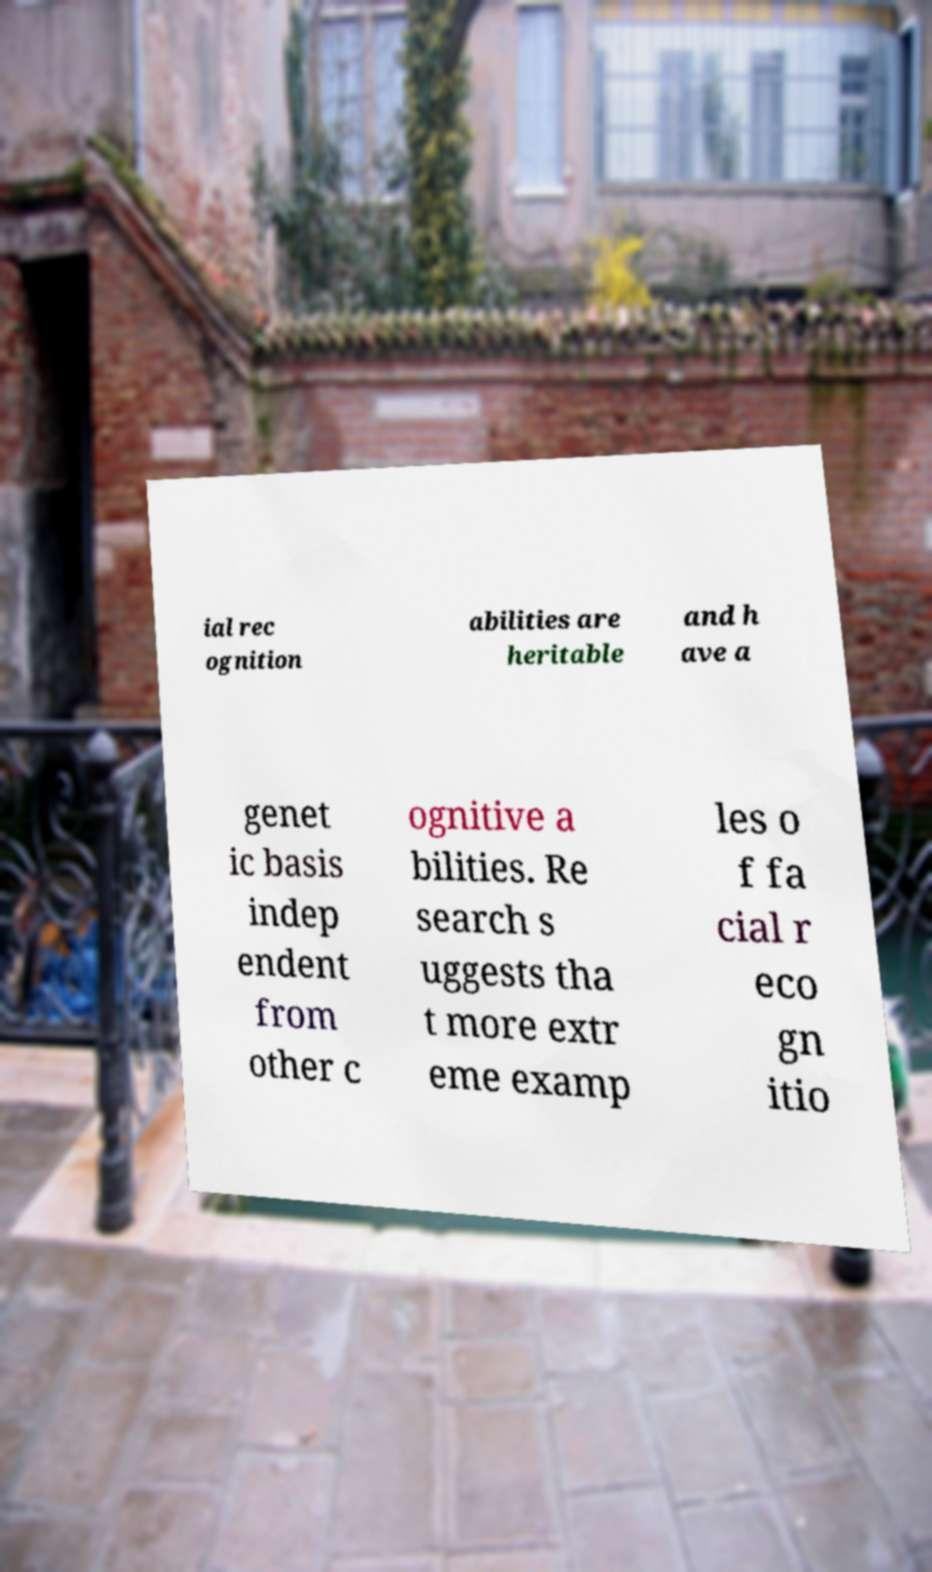Please read and relay the text visible in this image. What does it say? ial rec ognition abilities are heritable and h ave a genet ic basis indep endent from other c ognitive a bilities. Re search s uggests tha t more extr eme examp les o f fa cial r eco gn itio 